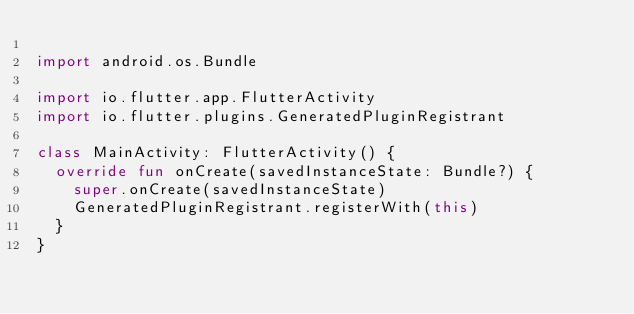Convert code to text. <code><loc_0><loc_0><loc_500><loc_500><_Kotlin_>
import android.os.Bundle

import io.flutter.app.FlutterActivity
import io.flutter.plugins.GeneratedPluginRegistrant

class MainActivity: FlutterActivity() {
  override fun onCreate(savedInstanceState: Bundle?) {
    super.onCreate(savedInstanceState)
    GeneratedPluginRegistrant.registerWith(this)
  }
}
</code> 